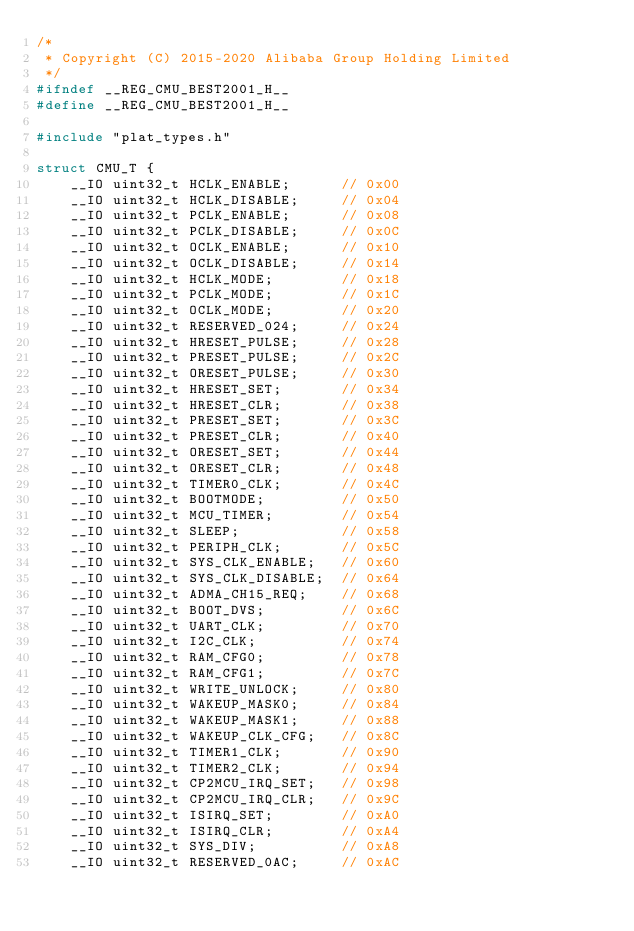<code> <loc_0><loc_0><loc_500><loc_500><_C_>/*
 * Copyright (C) 2015-2020 Alibaba Group Holding Limited
 */
#ifndef __REG_CMU_BEST2001_H__
#define __REG_CMU_BEST2001_H__

#include "plat_types.h"

struct CMU_T {
    __IO uint32_t HCLK_ENABLE;      // 0x00
    __IO uint32_t HCLK_DISABLE;     // 0x04
    __IO uint32_t PCLK_ENABLE;      // 0x08
    __IO uint32_t PCLK_DISABLE;     // 0x0C
    __IO uint32_t OCLK_ENABLE;      // 0x10
    __IO uint32_t OCLK_DISABLE;     // 0x14
    __IO uint32_t HCLK_MODE;        // 0x18
    __IO uint32_t PCLK_MODE;        // 0x1C
    __IO uint32_t OCLK_MODE;        // 0x20
    __IO uint32_t RESERVED_024;     // 0x24
    __IO uint32_t HRESET_PULSE;     // 0x28
    __IO uint32_t PRESET_PULSE;     // 0x2C
    __IO uint32_t ORESET_PULSE;     // 0x30
    __IO uint32_t HRESET_SET;       // 0x34
    __IO uint32_t HRESET_CLR;       // 0x38
    __IO uint32_t PRESET_SET;       // 0x3C
    __IO uint32_t PRESET_CLR;       // 0x40
    __IO uint32_t ORESET_SET;       // 0x44
    __IO uint32_t ORESET_CLR;       // 0x48
    __IO uint32_t TIMER0_CLK;       // 0x4C
    __IO uint32_t BOOTMODE;         // 0x50
    __IO uint32_t MCU_TIMER;        // 0x54
    __IO uint32_t SLEEP;            // 0x58
    __IO uint32_t PERIPH_CLK;       // 0x5C
    __IO uint32_t SYS_CLK_ENABLE;   // 0x60
    __IO uint32_t SYS_CLK_DISABLE;  // 0x64
    __IO uint32_t ADMA_CH15_REQ;    // 0x68
    __IO uint32_t BOOT_DVS;         // 0x6C
    __IO uint32_t UART_CLK;         // 0x70
    __IO uint32_t I2C_CLK;          // 0x74
    __IO uint32_t RAM_CFG0;         // 0x78
    __IO uint32_t RAM_CFG1;         // 0x7C
    __IO uint32_t WRITE_UNLOCK;     // 0x80
    __IO uint32_t WAKEUP_MASK0;     // 0x84
    __IO uint32_t WAKEUP_MASK1;     // 0x88
    __IO uint32_t WAKEUP_CLK_CFG;   // 0x8C
    __IO uint32_t TIMER1_CLK;       // 0x90
    __IO uint32_t TIMER2_CLK;       // 0x94
    __IO uint32_t CP2MCU_IRQ_SET;   // 0x98
    __IO uint32_t CP2MCU_IRQ_CLR;   // 0x9C
    __IO uint32_t ISIRQ_SET;        // 0xA0
    __IO uint32_t ISIRQ_CLR;        // 0xA4
    __IO uint32_t SYS_DIV;          // 0xA8
    __IO uint32_t RESERVED_0AC;     // 0xAC</code> 